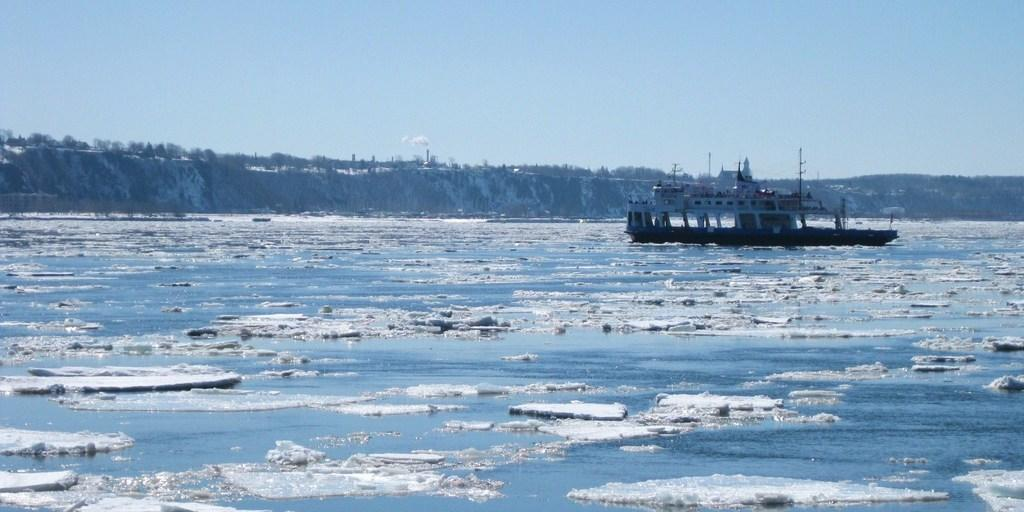What type of setting is depicted in the image? The image is an outside view. What can be seen on the right side of the image? There is a boat on the water on the right side of the image. What type of vegetation is visible in the background of the image? There are trees in the background of the image. What is visible at the top of the image? The sky is visible at the top of the image. How many bridges are visible in the image? There are no bridges present in the image. What type of powder is being used by the people in the image? There are no people or powder visible in the image. 